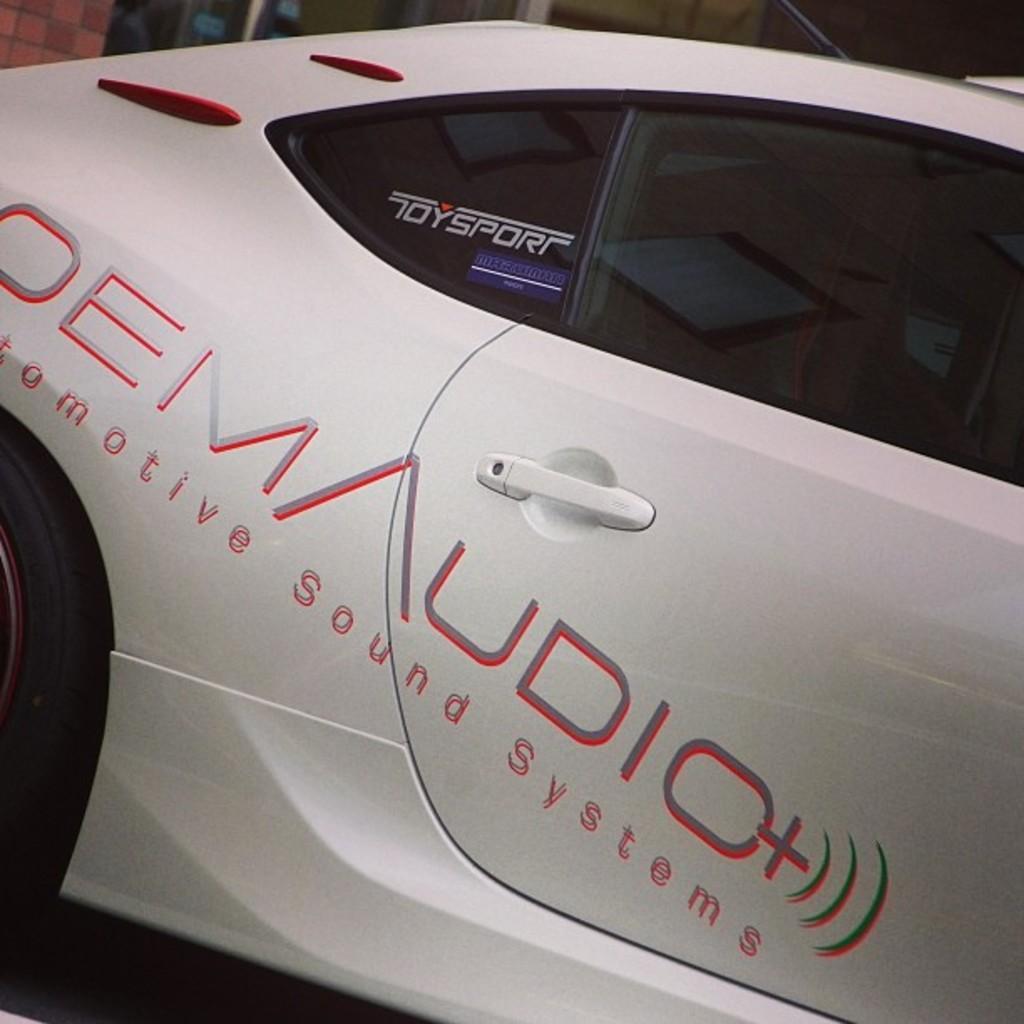Could you give a brief overview of what you see in this image? This is a zoomed in picture. In the foreground there is a white color car seems to be parked on the ground and we can see the text on the car. In the background we can see the metal rods and some other objects. 